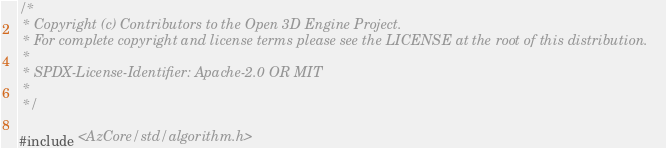Convert code to text. <code><loc_0><loc_0><loc_500><loc_500><_C++_>/*
 * Copyright (c) Contributors to the Open 3D Engine Project.
 * For complete copyright and license terms please see the LICENSE at the root of this distribution.
 *
 * SPDX-License-Identifier: Apache-2.0 OR MIT
 *
 */

#include <AzCore/std/algorithm.h></code> 